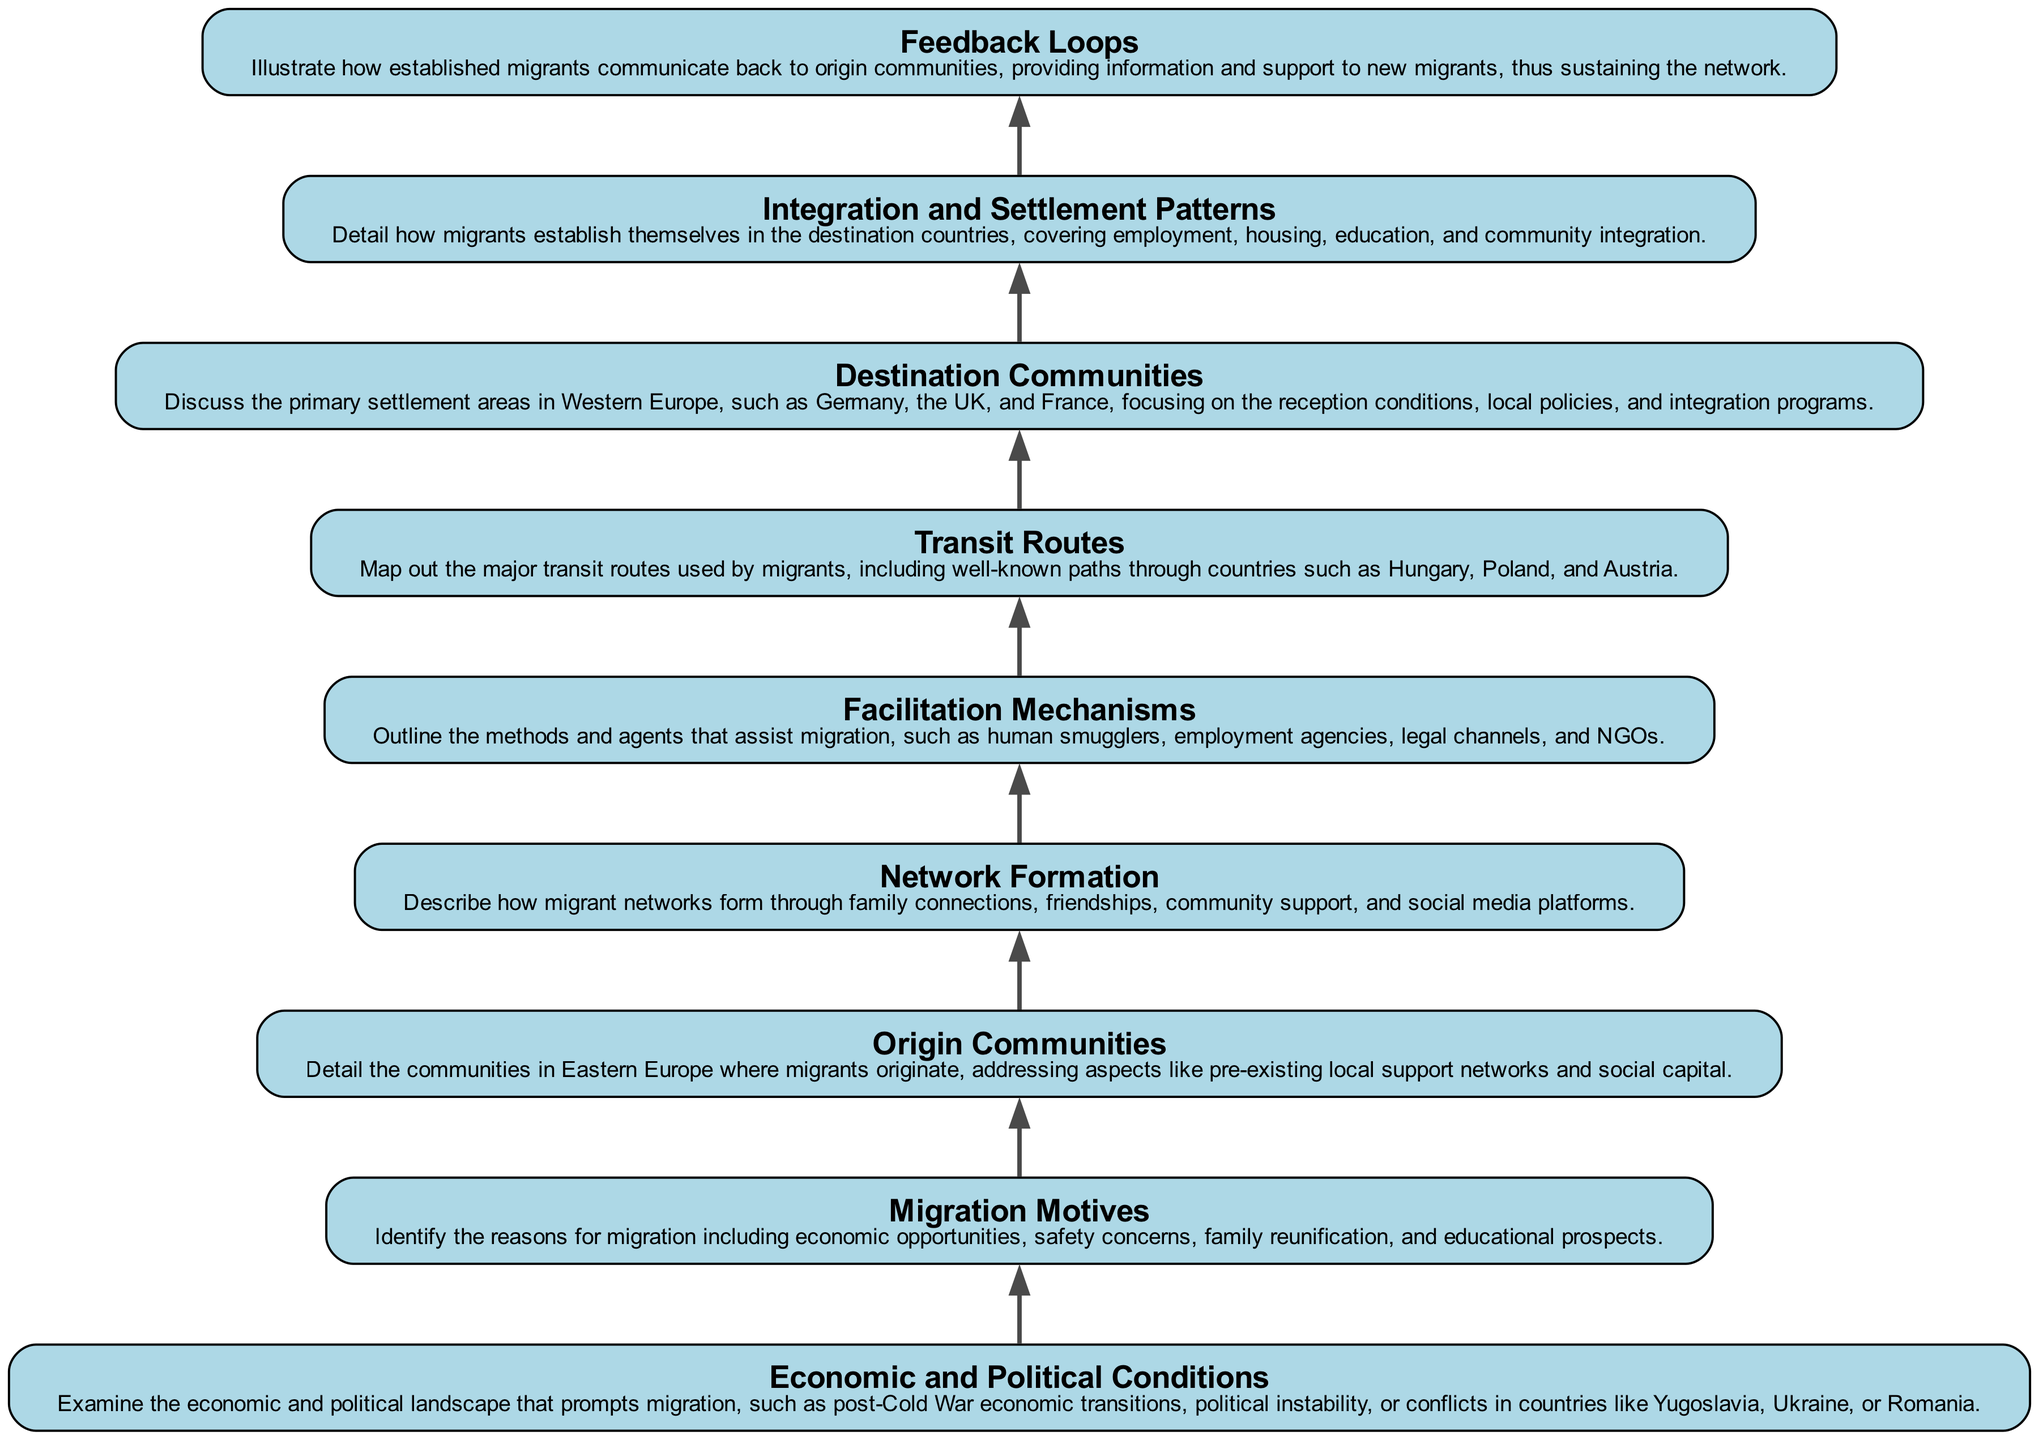What are the major migrant motives detailed in the diagram? The diagram indicates several migrant motives including economic opportunities, safety concerns, family reunification, and educational prospects. These motives are outlined in the 'Migration Motives' node.
Answer: economic opportunities, safety concerns, family reunification, educational prospects How many elements are included in the flow chart? The flow chart contains 9 elements, as detailed in the list of nodes from 'Economic and Political Conditions' to 'Feedback Loops'.
Answer: 9 Which node represents the community where migrants originate? The relevant node discussing the origin of migrants is titled 'Origin Communities'. This node specifically addresses aspects like pre-existing local support networks and social capital.
Answer: Origin Communities What follows Network Formation in the flow chart? The node that follows 'Network Formation' in the diagram is 'Facilitation Mechanisms', indicating the methods and agents assisting migration.
Answer: Facilitation Mechanisms How do established migrants contribute to the networks according to the diagram? Established migrants are shown to communicate back to origin communities, providing information and support to new migrants, which sustains the network. This is explained in the 'Feedback Loops' node.
Answer: Feedback Loops What type of routes are illustrated in the diagram for migrant transit? The diagram illustrates major 'Transit Routes' used by migrants, specifically detailing well-known paths through countries such as Hungary, Poland, and Austria.
Answer: Transit Routes What is the primary focus of the destination communities? The 'Destination Communities' node focuses on the primary settlement areas in Western Europe such as Germany, the UK, and France, along with details on reception conditions and integration programs.
Answer: Destination Communities What mechanisms assist in migration as depicted in the diagram? The 'Facilitation Mechanisms' node outlines methods and agents like human smugglers, employment agencies, legal channels, and NGOs that assist in migration.
Answer: Facilitation Mechanisms 